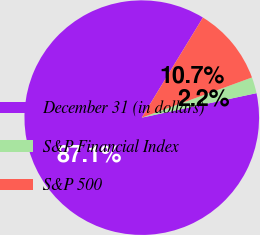Convert chart. <chart><loc_0><loc_0><loc_500><loc_500><pie_chart><fcel>December 31 (in dollars)<fcel>S&P Financial Index<fcel>S&P 500<nl><fcel>87.08%<fcel>2.22%<fcel>10.7%<nl></chart> 